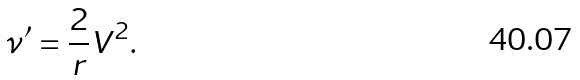Convert formula to latex. <formula><loc_0><loc_0><loc_500><loc_500>\nu ^ { \prime } = \frac { 2 } { r } V ^ { 2 } .</formula> 